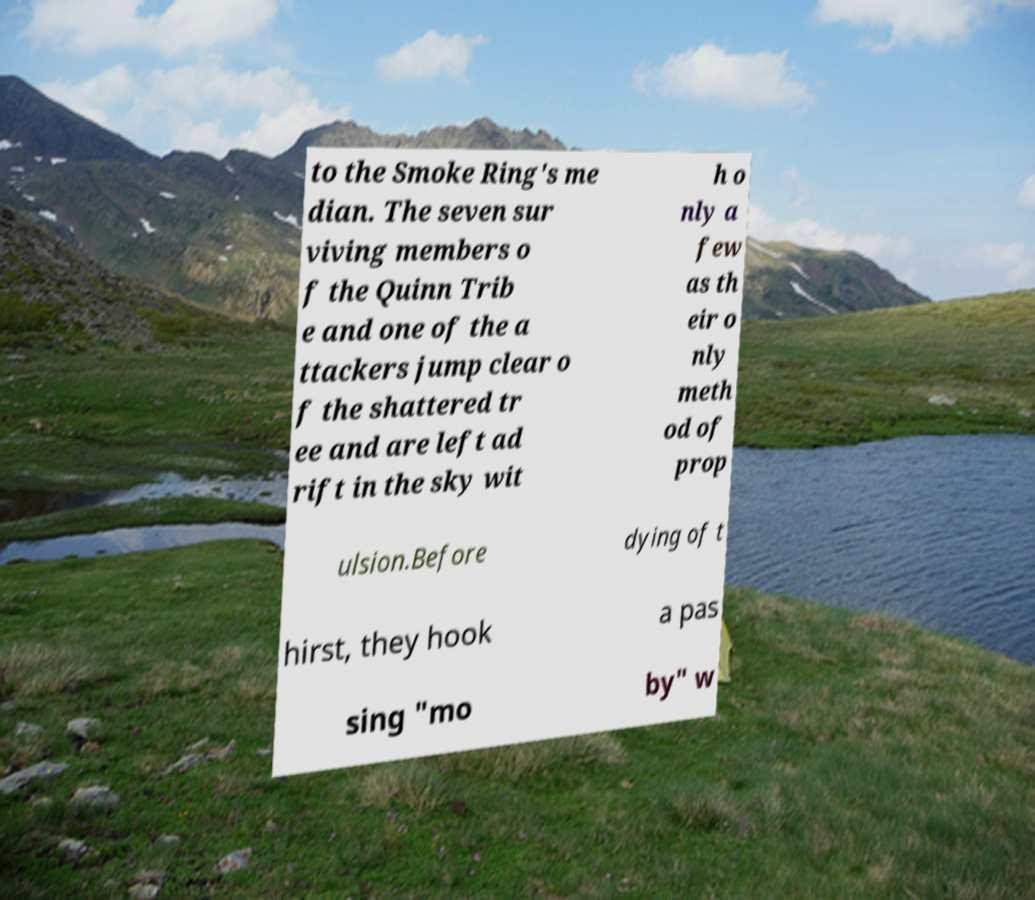Please identify and transcribe the text found in this image. to the Smoke Ring's me dian. The seven sur viving members o f the Quinn Trib e and one of the a ttackers jump clear o f the shattered tr ee and are left ad rift in the sky wit h o nly a few as th eir o nly meth od of prop ulsion.Before dying of t hirst, they hook a pas sing "mo by" w 